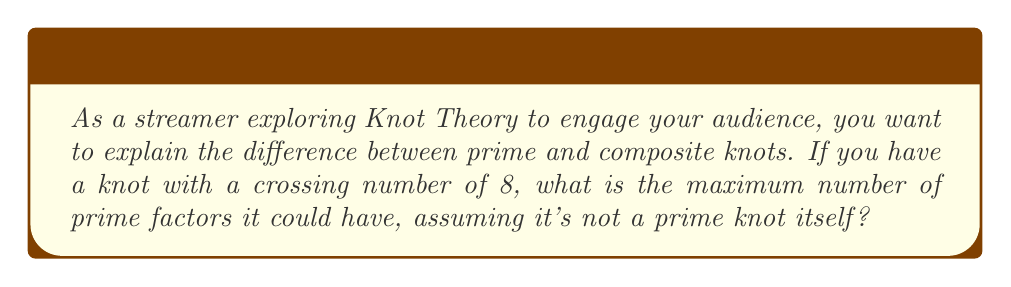Give your solution to this math problem. Let's approach this step-by-step:

1) First, recall that a prime knot is a non-trivial knot that cannot be decomposed into the connected sum of two non-trivial knots. A composite knot is one that can be decomposed into such a sum.

2) The crossing number of a knot is the minimum number of crossings in any diagram of the knot. In this case, we have a knot with a crossing number of 8.

3) An important theorem in Knot Theory states that for two knots $K_1$ and $K_2$ with crossing numbers $c_1$ and $c_2$ respectively, their connected sum $K_1 \# K_2$ has a crossing number $c$ that satisfies:

   $$c_1 + c_2 - 2 \leq c \leq c_1 + c_2$$

4) The smallest non-trivial knot is the trefoil knot, which has a crossing number of 3.

5) To maximize the number of prime factors, we need to decompose our knot into as many prime knots as possible, each with the smallest possible crossing number.

6) Let's start decomposing:
   8 = 3 + 3 + 2
   
   This means we can have at most two trefoil knots (crossing number 3 each) and still have 2 crossings left over.

7) However, remember that when we take the connected sum, we can lose up to 2 crossings for each connection. So this decomposition is valid.

8) Therefore, the maximum number of prime factors is 3: two trefoil knots and one Hopf link (the only non-trivial knot with 2 crossings, which is actually a link but counts as a prime factor in this context).
Answer: 3 